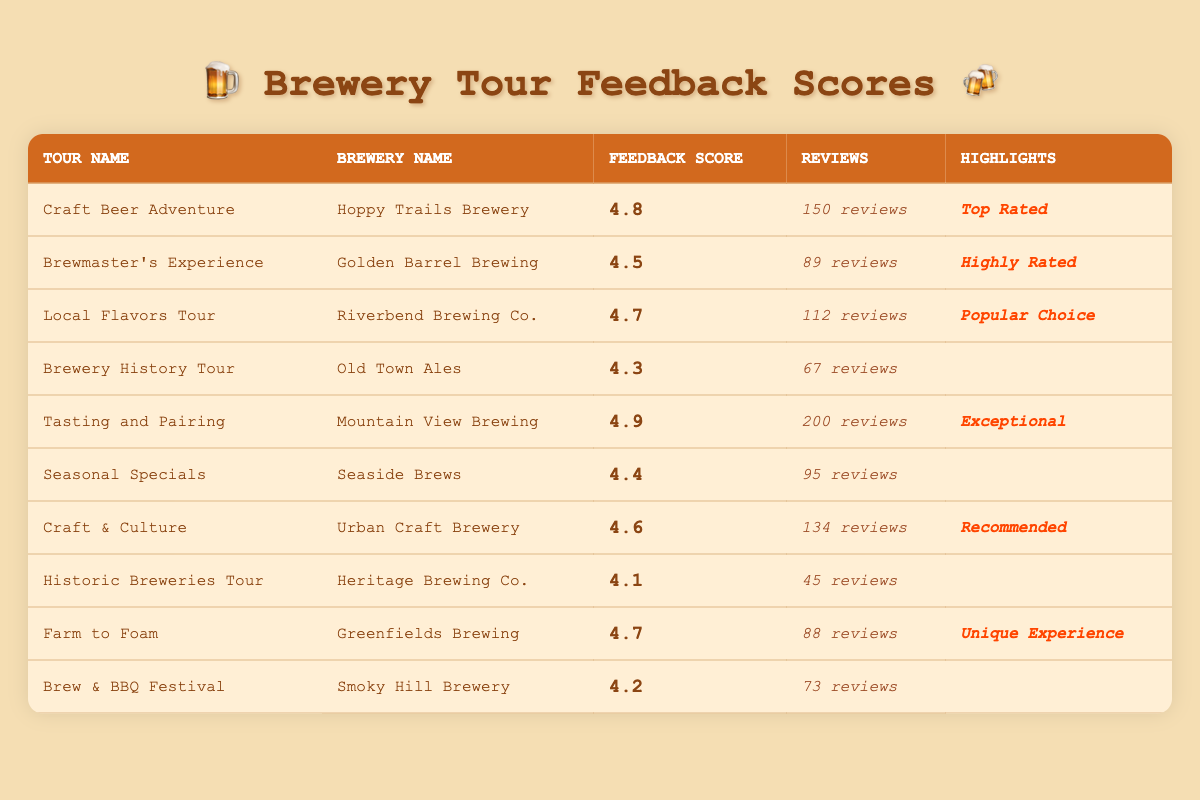What is the customer feedback score for "Tasting and Pairing" tour? The customer feedback score for the "Tasting and Pairing" tour is located in the corresponding row for this tour. It is noted as 4.9.
Answer: 4.9 Which brewery has the highest customer feedback score? To find the highest feedback score, I look through the scores listed. "Tasting and Pairing" has the highest score of 4.9.
Answer: Tasting and Pairing How many reviews did the "Farm to Foam" tour receive? The number of reviews for "Farm to Foam" is found in the corresponding row. It is listed as 88 reviews.
Answer: 88 reviews Is "Brewmaster's Experience" rated as a top choice? The highlighted column indicates whether a tour is noteworthy. "Brewmaster's Experience" has the label "Highly Rated," but it is not classified as a top choice.
Answer: No What is the average customer feedback score for all brewery tours listed in the table? First, I sum all the feedback scores: (4.8 + 4.5 + 4.7 + 4.3 + 4.9 + 4.4 + 4.6 + 4.1 + 4.7 + 4.2) = 46.2. There are 10 tours, so I divide 46.2 by 10 to get the average: 46.2 / 10 = 4.62.
Answer: 4.62 Which tour has the most reviews, and what is the score? I check the number of reviews for each tour. "Tasting and Pairing" has 200 reviews, which is the highest. Its feedback score is 4.9.
Answer: Tasting and Pairing: 200 reviews, 4.9 score What percentage of tours are rated above 4.5? I count the tours with a score above 4.5: "Craft Beer Adventure," "Local Flavors Tour," "Tasting and Pairing," "Craft & Culture," and "Farm to Foam" (5 tours). There are 10 total tours, so the percentage is (5/10) * 100 = 50%.
Answer: 50% Is there any tour that received fewer than 50 reviews? Reviewing the number of reviews, "Historic Breweries Tour" received 45 reviews, which is less than 50.
Answer: Yes Which brewery has the label "Unique Experience," and what is its score? I look for the highlighted label "Unique Experience" in the table. It is associated with "Farm to Foam," which has a score of 4.7.
Answer: Greenfields Brewing, 4.7 score What is the difference in customer feedback scores between the highest and lowest rated tours? The highest score is 4.9 (Tasting and Pairing) and the lowest score is 4.1 (Historic Breweries Tour). The difference is 4.9 - 4.1 = 0.8.
Answer: 0.8 How many tours have the status "Top Rated?" I scan through the highlighted column to find "Top Rated." There is only one tour, "Craft Beer Adventure," that has this status.
Answer: 1 